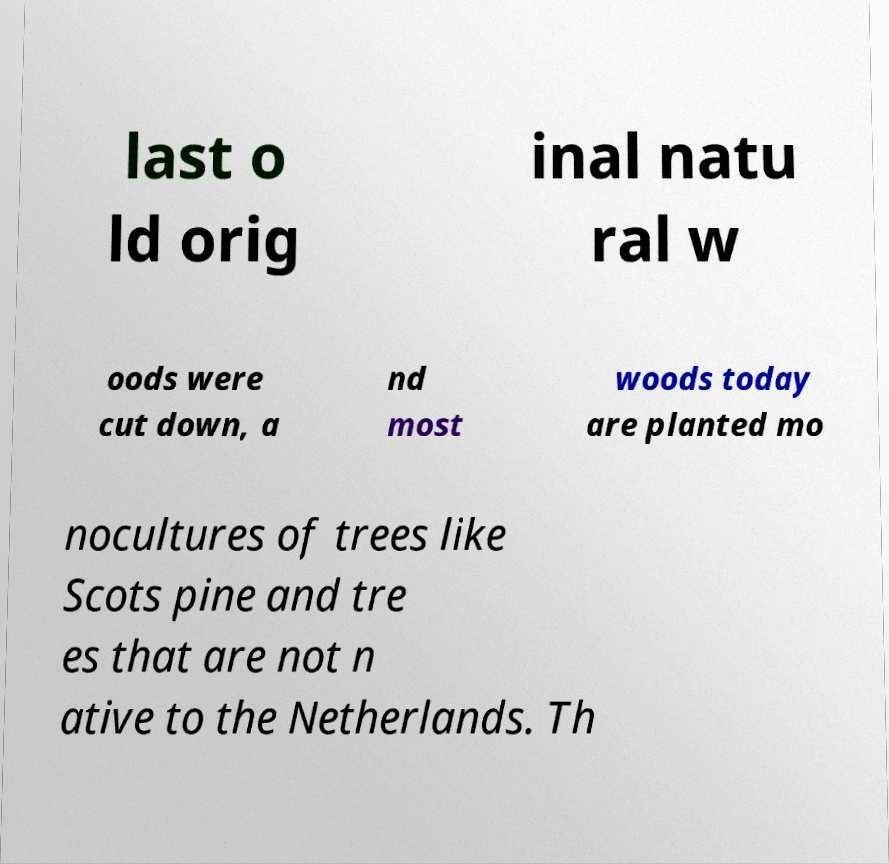There's text embedded in this image that I need extracted. Can you transcribe it verbatim? last o ld orig inal natu ral w oods were cut down, a nd most woods today are planted mo nocultures of trees like Scots pine and tre es that are not n ative to the Netherlands. Th 